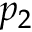<formula> <loc_0><loc_0><loc_500><loc_500>p _ { 2 }</formula> 